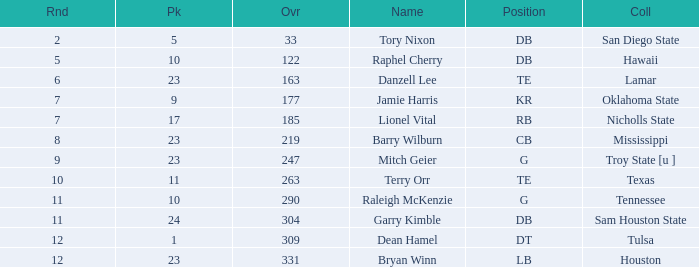Which Overall is the highest one that has a Name of raleigh mckenzie, and a Pick larger than 10? None. 